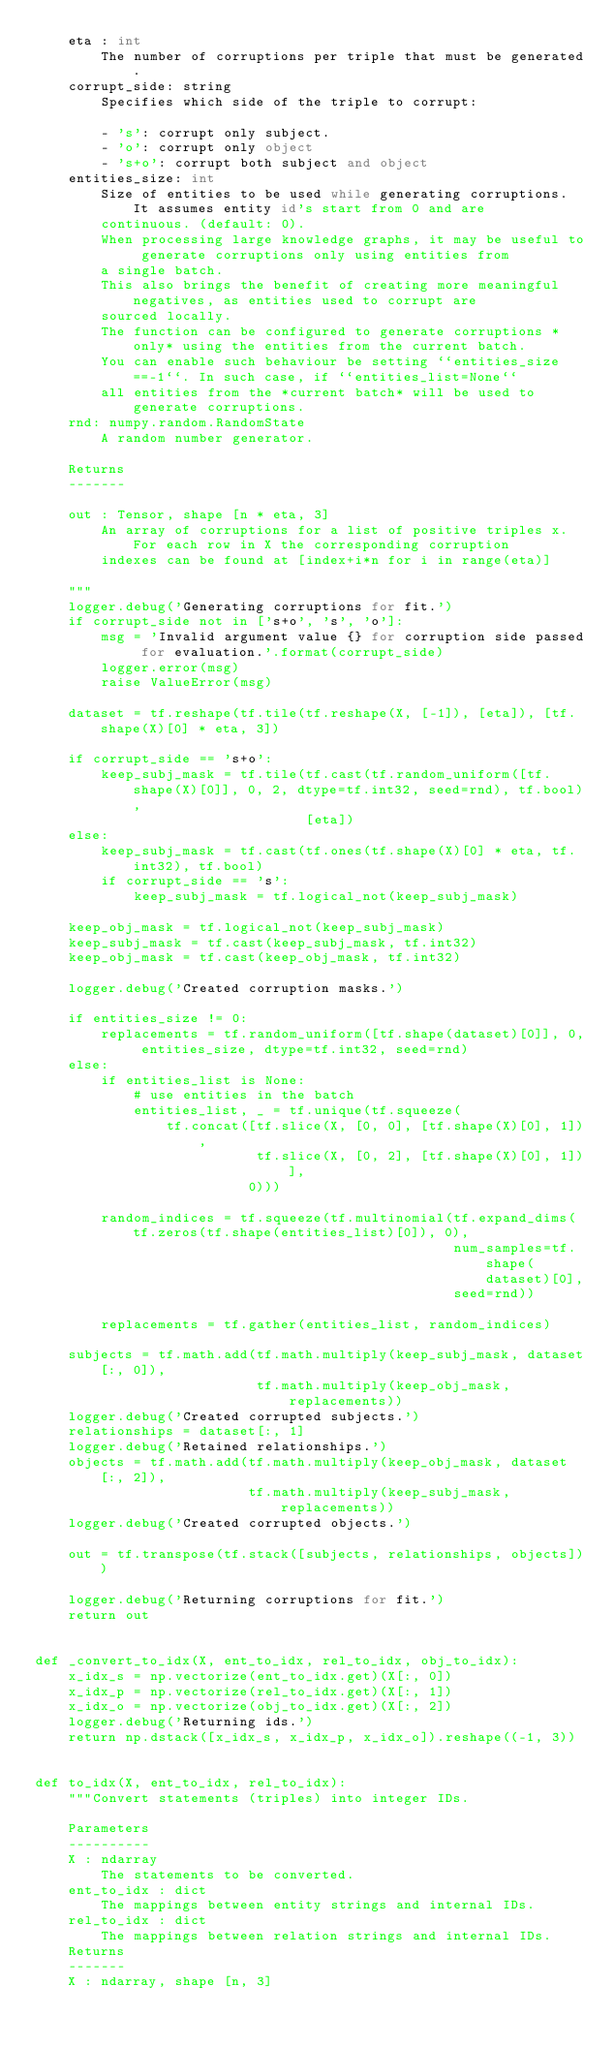Convert code to text. <code><loc_0><loc_0><loc_500><loc_500><_Python_>    eta : int
        The number of corruptions per triple that must be generated.
    corrupt_side: string
        Specifies which side of the triple to corrupt:

        - 's': corrupt only subject.
        - 'o': corrupt only object
        - 's+o': corrupt both subject and object
    entities_size: int
        Size of entities to be used while generating corruptions. It assumes entity id's start from 0 and are
        continuous. (default: 0).
        When processing large knowledge graphs, it may be useful to generate corruptions only using entities from
        a single batch.
        This also brings the benefit of creating more meaningful negatives, as entities used to corrupt are
        sourced locally.
        The function can be configured to generate corruptions *only* using the entities from the current batch.
        You can enable such behaviour be setting ``entities_size==-1``. In such case, if ``entities_list=None``
        all entities from the *current batch* will be used to generate corruptions.
    rnd: numpy.random.RandomState
        A random number generator.

    Returns
    -------

    out : Tensor, shape [n * eta, 3]
        An array of corruptions for a list of positive triples x. For each row in X the corresponding corruption
        indexes can be found at [index+i*n for i in range(eta)]

    """
    logger.debug('Generating corruptions for fit.')
    if corrupt_side not in ['s+o', 's', 'o']:
        msg = 'Invalid argument value {} for corruption side passed for evaluation.'.format(corrupt_side)
        logger.error(msg)
        raise ValueError(msg)

    dataset = tf.reshape(tf.tile(tf.reshape(X, [-1]), [eta]), [tf.shape(X)[0] * eta, 3])

    if corrupt_side == 's+o':
        keep_subj_mask = tf.tile(tf.cast(tf.random_uniform([tf.shape(X)[0]], 0, 2, dtype=tf.int32, seed=rnd), tf.bool),
                                 [eta])
    else:
        keep_subj_mask = tf.cast(tf.ones(tf.shape(X)[0] * eta, tf.int32), tf.bool)
        if corrupt_side == 's':
            keep_subj_mask = tf.logical_not(keep_subj_mask)

    keep_obj_mask = tf.logical_not(keep_subj_mask)
    keep_subj_mask = tf.cast(keep_subj_mask, tf.int32)
    keep_obj_mask = tf.cast(keep_obj_mask, tf.int32)

    logger.debug('Created corruption masks.')

    if entities_size != 0:
        replacements = tf.random_uniform([tf.shape(dataset)[0]], 0, entities_size, dtype=tf.int32, seed=rnd)
    else:
        if entities_list is None:
            # use entities in the batch
            entities_list, _ = tf.unique(tf.squeeze(
                tf.concat([tf.slice(X, [0, 0], [tf.shape(X)[0], 1]),
                           tf.slice(X, [0, 2], [tf.shape(X)[0], 1])],
                          0)))

        random_indices = tf.squeeze(tf.multinomial(tf.expand_dims(tf.zeros(tf.shape(entities_list)[0]), 0),
                                                   num_samples=tf.shape(dataset)[0],
                                                   seed=rnd))

        replacements = tf.gather(entities_list, random_indices)

    subjects = tf.math.add(tf.math.multiply(keep_subj_mask, dataset[:, 0]),
                           tf.math.multiply(keep_obj_mask, replacements))
    logger.debug('Created corrupted subjects.')
    relationships = dataset[:, 1]
    logger.debug('Retained relationships.')
    objects = tf.math.add(tf.math.multiply(keep_obj_mask, dataset[:, 2]),
                          tf.math.multiply(keep_subj_mask, replacements))
    logger.debug('Created corrupted objects.')

    out = tf.transpose(tf.stack([subjects, relationships, objects]))

    logger.debug('Returning corruptions for fit.')
    return out


def _convert_to_idx(X, ent_to_idx, rel_to_idx, obj_to_idx):
    x_idx_s = np.vectorize(ent_to_idx.get)(X[:, 0])
    x_idx_p = np.vectorize(rel_to_idx.get)(X[:, 1])
    x_idx_o = np.vectorize(obj_to_idx.get)(X[:, 2])
    logger.debug('Returning ids.')
    return np.dstack([x_idx_s, x_idx_p, x_idx_o]).reshape((-1, 3))


def to_idx(X, ent_to_idx, rel_to_idx):
    """Convert statements (triples) into integer IDs.

    Parameters
    ----------
    X : ndarray
        The statements to be converted.
    ent_to_idx : dict
        The mappings between entity strings and internal IDs.
    rel_to_idx : dict
        The mappings between relation strings and internal IDs.
    Returns
    -------
    X : ndarray, shape [n, 3]</code> 